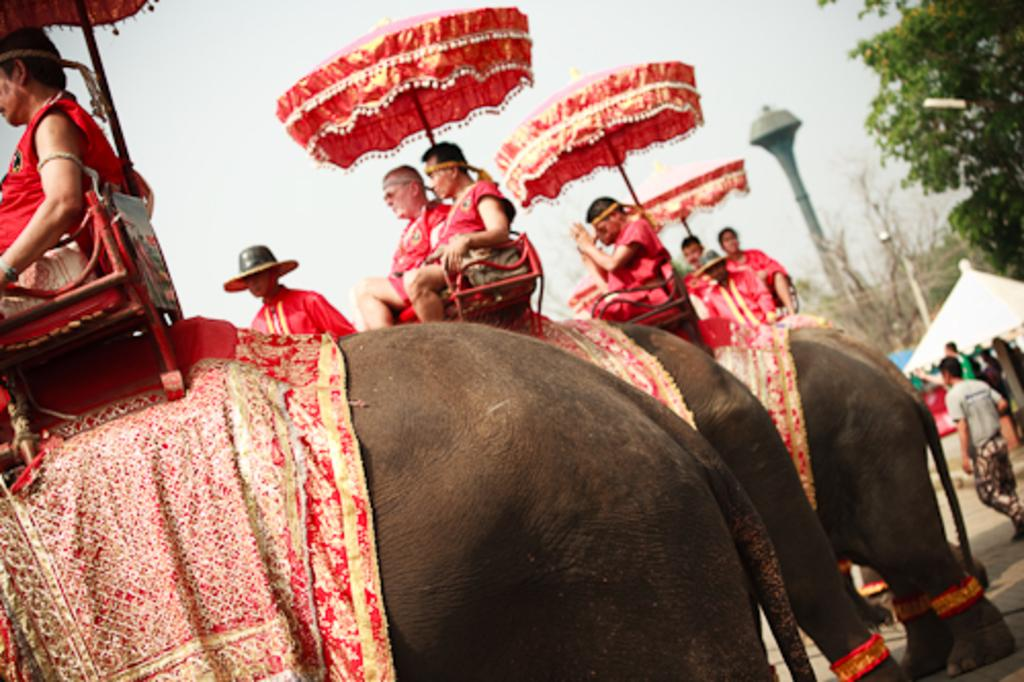What animals are present in the image? There is a group of elephants in the image. What are the people on the elephants doing? Each person on the elephants is holding an umbrella. What can be seen in the background of the image? There is a tree, a group of people, a tent, and a tower in the background of the image. What type of steel is used to construct the slope in the image? There is no slope or steel present in the image; it features a group of elephants with people holding umbrellas, along with a background that includes a tree, a group of people, a tent, and a tower. 